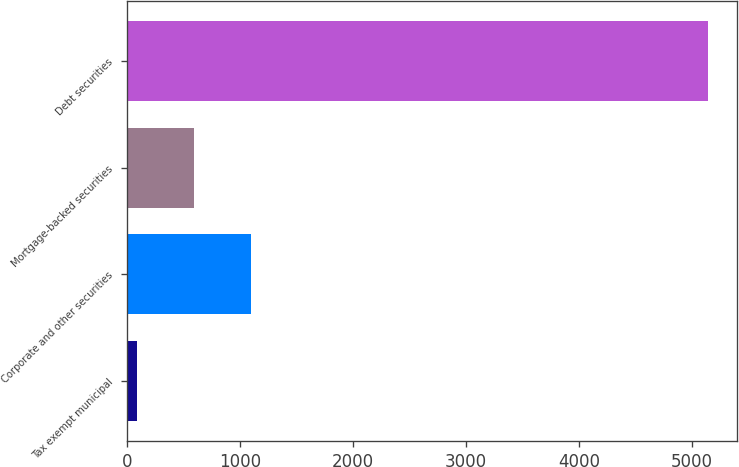<chart> <loc_0><loc_0><loc_500><loc_500><bar_chart><fcel>Tax exempt municipal<fcel>Corporate and other securities<fcel>Mortgage-backed securities<fcel>Debt securities<nl><fcel>90<fcel>1099.8<fcel>594.9<fcel>5139<nl></chart> 